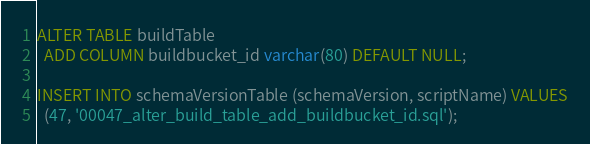Convert code to text. <code><loc_0><loc_0><loc_500><loc_500><_SQL_>ALTER TABLE buildTable
  ADD COLUMN buildbucket_id varchar(80) DEFAULT NULL;

INSERT INTO schemaVersionTable (schemaVersion, scriptName) VALUES
  (47, '00047_alter_build_table_add_buildbucket_id.sql');
</code> 